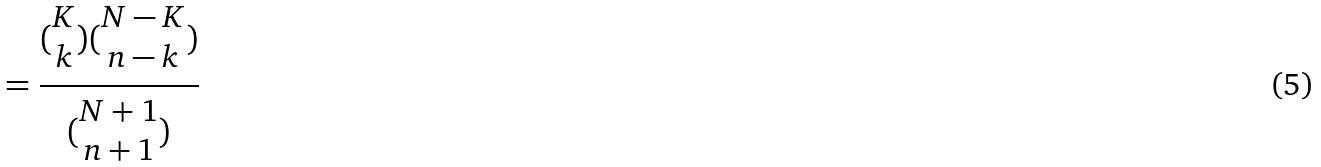Convert formula to latex. <formula><loc_0><loc_0><loc_500><loc_500>= \frac { ( \begin{matrix} K \\ k \end{matrix} ) ( \begin{matrix} N - K \\ n - k \end{matrix} ) } { ( \begin{matrix} N + 1 \\ n + 1 \end{matrix} ) }</formula> 